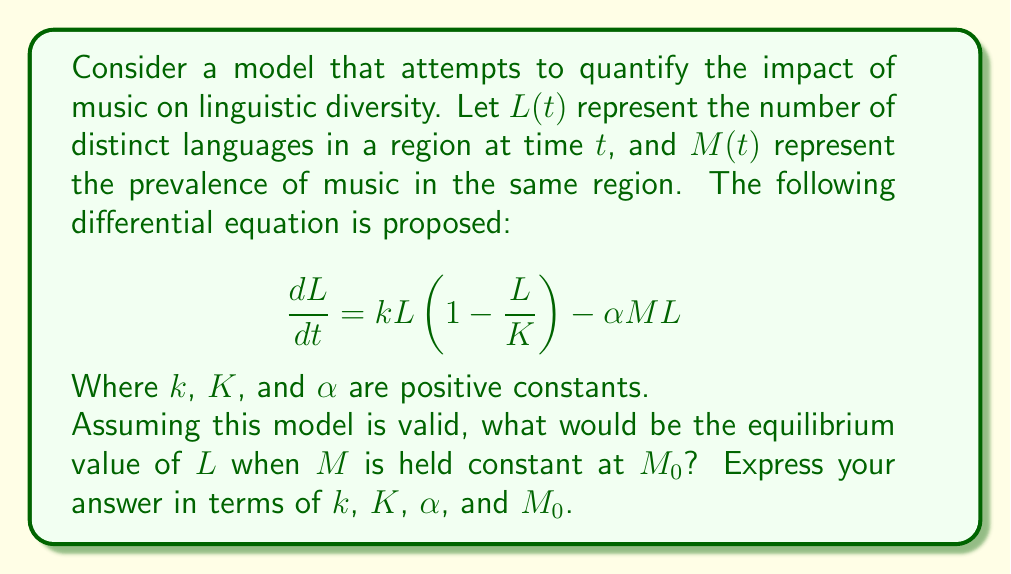Help me with this question. To find the equilibrium value of $L$, we need to set $\frac{dL}{dt} = 0$ and solve for $L$. This approach might be questioned by a skeptic, as it assumes the model accurately represents the complex relationship between music and linguistic diversity.

1) Set the derivative to zero:
   $$0 = kL(1-\frac{L}{K}) - \alpha M_0 L$$

2) Factor out $L$:
   $$0 = L(k(1-\frac{L}{K}) - \alpha M_0)$$

3) This equation is satisfied when either $L = 0$ or when the term in parentheses is zero. Let's focus on the non-trivial solution:
   $$k(1-\frac{L}{K}) - \alpha M_0 = 0$$

4) Solve for $L$:
   $$k - \frac{kL}{K} = \alpha M_0$$
   $$k - \alpha M_0 = \frac{kL}{K}$$
   $$K(k - \alpha M_0) = kL$$
   $$L = \frac{K(k - \alpha M_0)}{k}$$

5) Simplify:
   $$L = K(1 - \frac{\alpha M_0}{k})$$

This result suggests that the equilibrium number of languages decreases linearly with the prevalence of music, which a skeptic might find overly simplistic given the complex nature of language evolution and cultural interactions.
Answer: $L = K(1 - \frac{\alpha M_0}{k})$ 